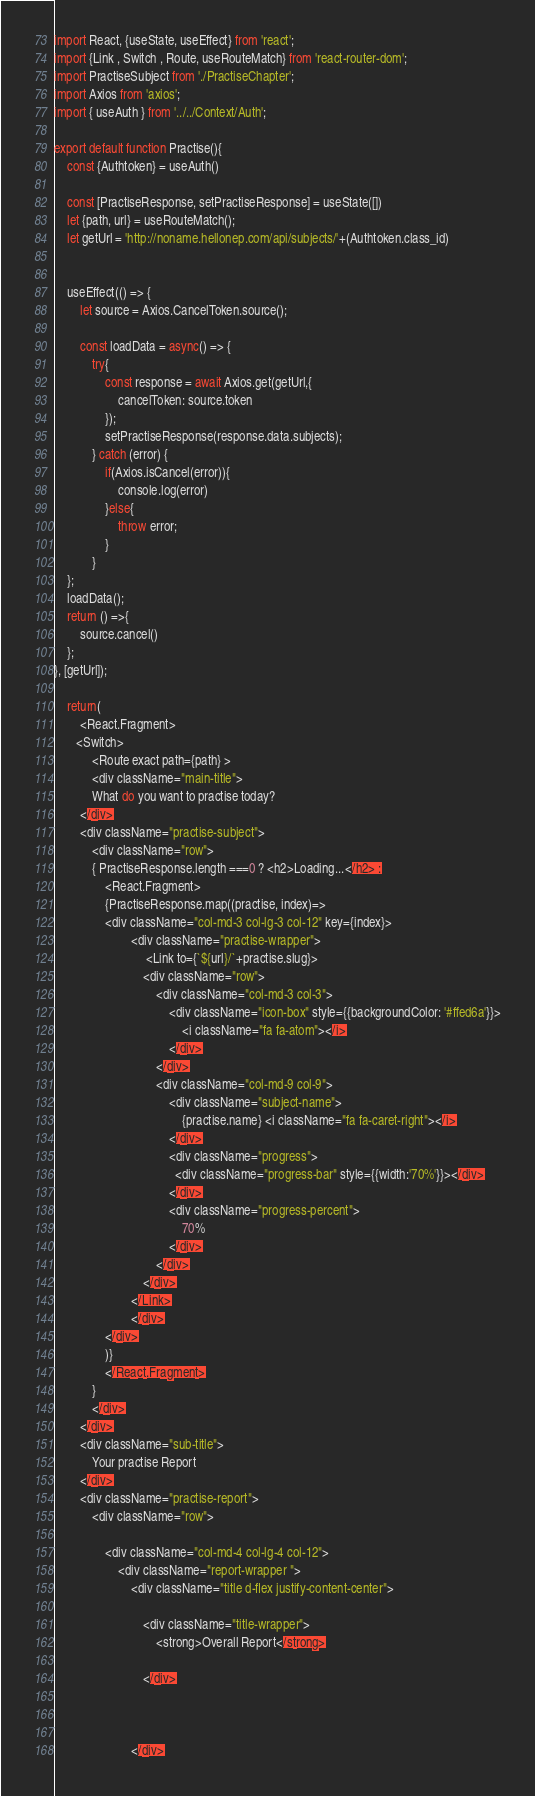<code> <loc_0><loc_0><loc_500><loc_500><_JavaScript_>import React, {useState, useEffect} from 'react';
import {Link , Switch , Route, useRouteMatch} from 'react-router-dom';
import PractiseSubject from './PractiseChapter';
import Axios from 'axios';
import { useAuth } from '../../Context/Auth';

export default function Practise(){
    const {Authtoken} = useAuth()
    
    const [PractiseResponse, setPractiseResponse] = useState([])
    let {path, url} = useRouteMatch();
    let getUrl = 'http://noname.hellonep.com/api/subjects/'+(Authtoken.class_id)
    

    useEffect(() => {
        let source = Axios.CancelToken.source();

        const loadData = async() => {
            try{
                const response = await Axios.get(getUrl,{
                    cancelToken: source.token
                });
                setPractiseResponse(response.data.subjects);
            } catch (error) {
                if(Axios.isCancel(error)){
                    console.log(error)
                }else{
                    throw error;
                }
            }
    };
    loadData();
    return () =>{
        source.cancel()
    };
}, [getUrl]);

    return(
        <React.Fragment>
       <Switch>
            <Route exact path={path} >
            <div className="main-title">
            What do you want to practise today?
        </div>
        <div className="practise-subject">
            <div className="row">
            { PractiseResponse.length ===0 ? <h2>Loading...</h2> :
                <React.Fragment>
                {PractiseResponse.map((practise, index)=>
                <div className="col-md-3 col-lg-3 col-12" key={index}>  
                        <div className="practise-wrapper">
                             <Link to={`${url}/`+practise.slug}>
                            <div className="row">
                                <div className="col-md-3 col-3">
                                    <div className="icon-box" style={{backgroundColor: '#ffed6a'}}>
                                        <i className="fa fa-atom"></i>
                                    </div>
                                </div>
                                <div className="col-md-9 col-9">
                                    <div className="subject-name">
                                        {practise.name} <i className="fa fa-caret-right"></i>
                                    </div>
                                    <div className="progress">
                                      <div className="progress-bar" style={{width:'70%'}}></div>
                                    </div>
                                    <div className="progress-percent">
                                        70%
                                    </div>
                                </div>
                            </div>
                        </Link>
                        </div>
                </div>
                )}
                </React.Fragment>
            }
            </div>
        </div>
        <div className="sub-title">
            Your practise Report
        </div>
        <div className="practise-report">
            <div className="row">
                
                <div className="col-md-4 col-lg-4 col-12">
                    <div className="report-wrapper ">
                        <div className="title d-flex justify-content-center">
                           
                            <div className="title-wrapper">
                                <strong>Overall Report</strong>
                               
                            </div>

                           

                        </div></code> 